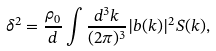<formula> <loc_0><loc_0><loc_500><loc_500>\delta ^ { 2 } = \frac { \rho _ { 0 } } { d } \int \frac { d ^ { 3 } k } { ( 2 \pi ) ^ { 3 } } | { b } ( { k } ) | ^ { 2 } S ( { k } ) ,</formula> 